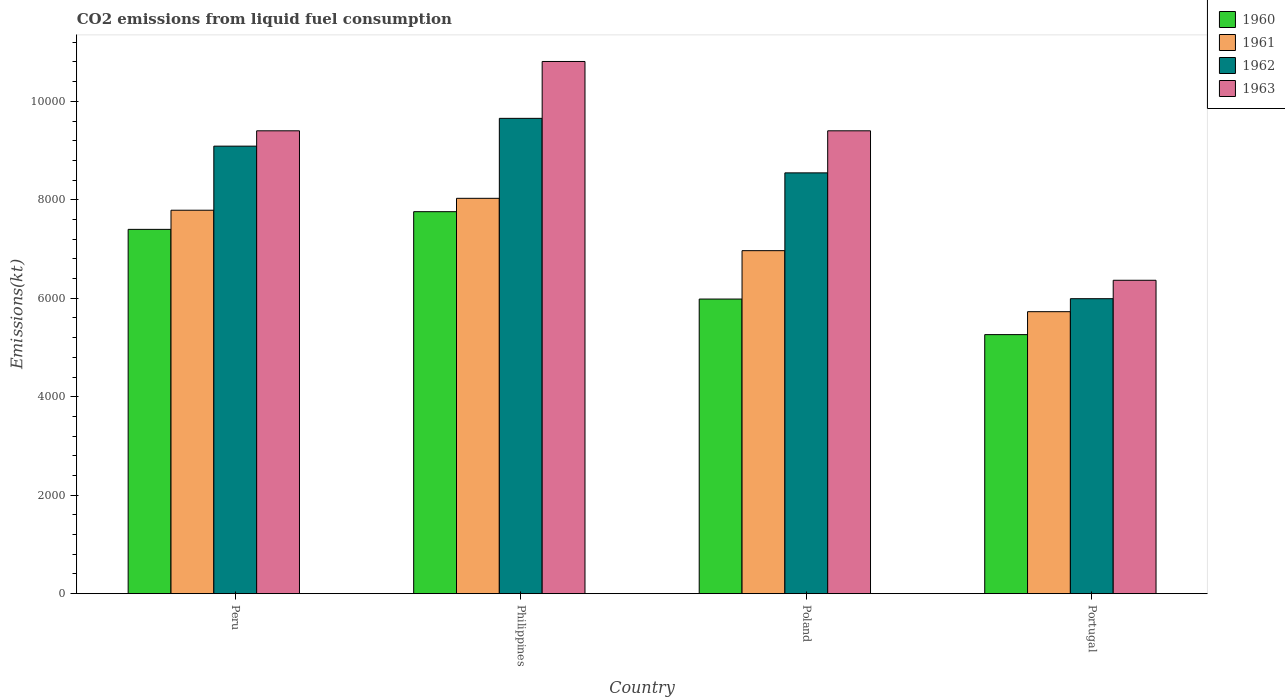Are the number of bars per tick equal to the number of legend labels?
Give a very brief answer. Yes. Are the number of bars on each tick of the X-axis equal?
Your answer should be compact. Yes. What is the label of the 2nd group of bars from the left?
Ensure brevity in your answer.  Philippines. What is the amount of CO2 emitted in 1960 in Poland?
Make the answer very short. 5984.54. Across all countries, what is the maximum amount of CO2 emitted in 1963?
Your answer should be compact. 1.08e+04. Across all countries, what is the minimum amount of CO2 emitted in 1960?
Provide a short and direct response. 5262.15. In which country was the amount of CO2 emitted in 1961 minimum?
Your answer should be very brief. Portugal. What is the total amount of CO2 emitted in 1963 in the graph?
Offer a very short reply. 3.60e+04. What is the difference between the amount of CO2 emitted in 1961 in Peru and that in Philippines?
Make the answer very short. -242.02. What is the difference between the amount of CO2 emitted in 1962 in Portugal and the amount of CO2 emitted in 1961 in Philippines?
Ensure brevity in your answer.  -2038.85. What is the average amount of CO2 emitted in 1962 per country?
Offer a very short reply. 8321.34. What is the difference between the amount of CO2 emitted of/in 1963 and amount of CO2 emitted of/in 1961 in Philippines?
Make the answer very short. 2779.59. What is the ratio of the amount of CO2 emitted in 1962 in Philippines to that in Poland?
Ensure brevity in your answer.  1.13. Is the amount of CO2 emitted in 1960 in Peru less than that in Portugal?
Provide a short and direct response. No. What is the difference between the highest and the second highest amount of CO2 emitted in 1963?
Your answer should be compact. -1408.13. What is the difference between the highest and the lowest amount of CO2 emitted in 1960?
Offer a very short reply. 2497.23. In how many countries, is the amount of CO2 emitted in 1960 greater than the average amount of CO2 emitted in 1960 taken over all countries?
Provide a succinct answer. 2. What does the 1st bar from the left in Peru represents?
Your answer should be very brief. 1960. What does the 1st bar from the right in Poland represents?
Your answer should be compact. 1963. Is it the case that in every country, the sum of the amount of CO2 emitted in 1963 and amount of CO2 emitted in 1961 is greater than the amount of CO2 emitted in 1962?
Your response must be concise. Yes. Are all the bars in the graph horizontal?
Your answer should be compact. No. What is the difference between two consecutive major ticks on the Y-axis?
Your answer should be very brief. 2000. Does the graph contain grids?
Your response must be concise. No. How many legend labels are there?
Offer a terse response. 4. What is the title of the graph?
Your response must be concise. CO2 emissions from liquid fuel consumption. What is the label or title of the Y-axis?
Ensure brevity in your answer.  Emissions(kt). What is the Emissions(kt) of 1960 in Peru?
Offer a terse response. 7400.01. What is the Emissions(kt) in 1961 in Peru?
Your response must be concise. 7788.71. What is the Emissions(kt) of 1962 in Peru?
Your response must be concise. 9090.49. What is the Emissions(kt) of 1963 in Peru?
Your answer should be very brief. 9402.19. What is the Emissions(kt) of 1960 in Philippines?
Provide a short and direct response. 7759.37. What is the Emissions(kt) in 1961 in Philippines?
Your response must be concise. 8030.73. What is the Emissions(kt) of 1962 in Philippines?
Your response must be concise. 9655.21. What is the Emissions(kt) of 1963 in Philippines?
Provide a short and direct response. 1.08e+04. What is the Emissions(kt) of 1960 in Poland?
Offer a terse response. 5984.54. What is the Emissions(kt) of 1961 in Poland?
Give a very brief answer. 6967.3. What is the Emissions(kt) in 1962 in Poland?
Provide a succinct answer. 8547.78. What is the Emissions(kt) of 1963 in Poland?
Offer a terse response. 9402.19. What is the Emissions(kt) of 1960 in Portugal?
Provide a short and direct response. 5262.15. What is the Emissions(kt) in 1961 in Portugal?
Offer a terse response. 5727.85. What is the Emissions(kt) of 1962 in Portugal?
Make the answer very short. 5991.88. What is the Emissions(kt) of 1963 in Portugal?
Give a very brief answer. 6365.91. Across all countries, what is the maximum Emissions(kt) of 1960?
Offer a terse response. 7759.37. Across all countries, what is the maximum Emissions(kt) in 1961?
Your answer should be compact. 8030.73. Across all countries, what is the maximum Emissions(kt) of 1962?
Provide a succinct answer. 9655.21. Across all countries, what is the maximum Emissions(kt) of 1963?
Your answer should be compact. 1.08e+04. Across all countries, what is the minimum Emissions(kt) of 1960?
Provide a succinct answer. 5262.15. Across all countries, what is the minimum Emissions(kt) in 1961?
Provide a short and direct response. 5727.85. Across all countries, what is the minimum Emissions(kt) of 1962?
Make the answer very short. 5991.88. Across all countries, what is the minimum Emissions(kt) of 1963?
Ensure brevity in your answer.  6365.91. What is the total Emissions(kt) in 1960 in the graph?
Make the answer very short. 2.64e+04. What is the total Emissions(kt) in 1961 in the graph?
Your answer should be very brief. 2.85e+04. What is the total Emissions(kt) in 1962 in the graph?
Give a very brief answer. 3.33e+04. What is the total Emissions(kt) of 1963 in the graph?
Your response must be concise. 3.60e+04. What is the difference between the Emissions(kt) in 1960 in Peru and that in Philippines?
Your answer should be very brief. -359.37. What is the difference between the Emissions(kt) of 1961 in Peru and that in Philippines?
Your answer should be very brief. -242.02. What is the difference between the Emissions(kt) in 1962 in Peru and that in Philippines?
Provide a succinct answer. -564.72. What is the difference between the Emissions(kt) in 1963 in Peru and that in Philippines?
Keep it short and to the point. -1408.13. What is the difference between the Emissions(kt) in 1960 in Peru and that in Poland?
Provide a succinct answer. 1415.46. What is the difference between the Emissions(kt) in 1961 in Peru and that in Poland?
Give a very brief answer. 821.41. What is the difference between the Emissions(kt) of 1962 in Peru and that in Poland?
Provide a succinct answer. 542.72. What is the difference between the Emissions(kt) in 1963 in Peru and that in Poland?
Offer a very short reply. 0. What is the difference between the Emissions(kt) of 1960 in Peru and that in Portugal?
Make the answer very short. 2137.86. What is the difference between the Emissions(kt) of 1961 in Peru and that in Portugal?
Offer a very short reply. 2060.85. What is the difference between the Emissions(kt) of 1962 in Peru and that in Portugal?
Offer a terse response. 3098.61. What is the difference between the Emissions(kt) of 1963 in Peru and that in Portugal?
Offer a very short reply. 3036.28. What is the difference between the Emissions(kt) of 1960 in Philippines and that in Poland?
Your response must be concise. 1774.83. What is the difference between the Emissions(kt) in 1961 in Philippines and that in Poland?
Make the answer very short. 1063.43. What is the difference between the Emissions(kt) of 1962 in Philippines and that in Poland?
Offer a terse response. 1107.43. What is the difference between the Emissions(kt) in 1963 in Philippines and that in Poland?
Offer a very short reply. 1408.13. What is the difference between the Emissions(kt) of 1960 in Philippines and that in Portugal?
Offer a terse response. 2497.23. What is the difference between the Emissions(kt) of 1961 in Philippines and that in Portugal?
Your response must be concise. 2302.88. What is the difference between the Emissions(kt) of 1962 in Philippines and that in Portugal?
Ensure brevity in your answer.  3663.33. What is the difference between the Emissions(kt) in 1963 in Philippines and that in Portugal?
Offer a terse response. 4444.4. What is the difference between the Emissions(kt) of 1960 in Poland and that in Portugal?
Ensure brevity in your answer.  722.4. What is the difference between the Emissions(kt) in 1961 in Poland and that in Portugal?
Offer a very short reply. 1239.45. What is the difference between the Emissions(kt) of 1962 in Poland and that in Portugal?
Your response must be concise. 2555.9. What is the difference between the Emissions(kt) in 1963 in Poland and that in Portugal?
Make the answer very short. 3036.28. What is the difference between the Emissions(kt) of 1960 in Peru and the Emissions(kt) of 1961 in Philippines?
Make the answer very short. -630.72. What is the difference between the Emissions(kt) of 1960 in Peru and the Emissions(kt) of 1962 in Philippines?
Your response must be concise. -2255.2. What is the difference between the Emissions(kt) in 1960 in Peru and the Emissions(kt) in 1963 in Philippines?
Your answer should be very brief. -3410.31. What is the difference between the Emissions(kt) in 1961 in Peru and the Emissions(kt) in 1962 in Philippines?
Ensure brevity in your answer.  -1866.5. What is the difference between the Emissions(kt) of 1961 in Peru and the Emissions(kt) of 1963 in Philippines?
Provide a succinct answer. -3021.61. What is the difference between the Emissions(kt) of 1962 in Peru and the Emissions(kt) of 1963 in Philippines?
Ensure brevity in your answer.  -1719.82. What is the difference between the Emissions(kt) of 1960 in Peru and the Emissions(kt) of 1961 in Poland?
Provide a succinct answer. 432.71. What is the difference between the Emissions(kt) in 1960 in Peru and the Emissions(kt) in 1962 in Poland?
Ensure brevity in your answer.  -1147.77. What is the difference between the Emissions(kt) of 1960 in Peru and the Emissions(kt) of 1963 in Poland?
Your answer should be compact. -2002.18. What is the difference between the Emissions(kt) in 1961 in Peru and the Emissions(kt) in 1962 in Poland?
Your answer should be compact. -759.07. What is the difference between the Emissions(kt) of 1961 in Peru and the Emissions(kt) of 1963 in Poland?
Your response must be concise. -1613.48. What is the difference between the Emissions(kt) in 1962 in Peru and the Emissions(kt) in 1963 in Poland?
Offer a terse response. -311.69. What is the difference between the Emissions(kt) in 1960 in Peru and the Emissions(kt) in 1961 in Portugal?
Offer a very short reply. 1672.15. What is the difference between the Emissions(kt) of 1960 in Peru and the Emissions(kt) of 1962 in Portugal?
Your answer should be compact. 1408.13. What is the difference between the Emissions(kt) in 1960 in Peru and the Emissions(kt) in 1963 in Portugal?
Ensure brevity in your answer.  1034.09. What is the difference between the Emissions(kt) in 1961 in Peru and the Emissions(kt) in 1962 in Portugal?
Keep it short and to the point. 1796.83. What is the difference between the Emissions(kt) in 1961 in Peru and the Emissions(kt) in 1963 in Portugal?
Provide a short and direct response. 1422.8. What is the difference between the Emissions(kt) of 1962 in Peru and the Emissions(kt) of 1963 in Portugal?
Offer a terse response. 2724.58. What is the difference between the Emissions(kt) of 1960 in Philippines and the Emissions(kt) of 1961 in Poland?
Give a very brief answer. 792.07. What is the difference between the Emissions(kt) in 1960 in Philippines and the Emissions(kt) in 1962 in Poland?
Give a very brief answer. -788.4. What is the difference between the Emissions(kt) in 1960 in Philippines and the Emissions(kt) in 1963 in Poland?
Keep it short and to the point. -1642.82. What is the difference between the Emissions(kt) in 1961 in Philippines and the Emissions(kt) in 1962 in Poland?
Offer a terse response. -517.05. What is the difference between the Emissions(kt) in 1961 in Philippines and the Emissions(kt) in 1963 in Poland?
Keep it short and to the point. -1371.46. What is the difference between the Emissions(kt) of 1962 in Philippines and the Emissions(kt) of 1963 in Poland?
Provide a short and direct response. 253.02. What is the difference between the Emissions(kt) in 1960 in Philippines and the Emissions(kt) in 1961 in Portugal?
Your answer should be very brief. 2031.52. What is the difference between the Emissions(kt) of 1960 in Philippines and the Emissions(kt) of 1962 in Portugal?
Keep it short and to the point. 1767.49. What is the difference between the Emissions(kt) of 1960 in Philippines and the Emissions(kt) of 1963 in Portugal?
Ensure brevity in your answer.  1393.46. What is the difference between the Emissions(kt) in 1961 in Philippines and the Emissions(kt) in 1962 in Portugal?
Provide a short and direct response. 2038.85. What is the difference between the Emissions(kt) in 1961 in Philippines and the Emissions(kt) in 1963 in Portugal?
Make the answer very short. 1664.82. What is the difference between the Emissions(kt) of 1962 in Philippines and the Emissions(kt) of 1963 in Portugal?
Your answer should be very brief. 3289.3. What is the difference between the Emissions(kt) of 1960 in Poland and the Emissions(kt) of 1961 in Portugal?
Offer a terse response. 256.69. What is the difference between the Emissions(kt) of 1960 in Poland and the Emissions(kt) of 1962 in Portugal?
Offer a very short reply. -7.33. What is the difference between the Emissions(kt) in 1960 in Poland and the Emissions(kt) in 1963 in Portugal?
Offer a very short reply. -381.37. What is the difference between the Emissions(kt) in 1961 in Poland and the Emissions(kt) in 1962 in Portugal?
Make the answer very short. 975.42. What is the difference between the Emissions(kt) of 1961 in Poland and the Emissions(kt) of 1963 in Portugal?
Provide a succinct answer. 601.39. What is the difference between the Emissions(kt) of 1962 in Poland and the Emissions(kt) of 1963 in Portugal?
Offer a terse response. 2181.86. What is the average Emissions(kt) of 1960 per country?
Provide a short and direct response. 6601.52. What is the average Emissions(kt) in 1961 per country?
Your answer should be compact. 7128.65. What is the average Emissions(kt) in 1962 per country?
Provide a succinct answer. 8321.34. What is the average Emissions(kt) of 1963 per country?
Provide a succinct answer. 8995.15. What is the difference between the Emissions(kt) of 1960 and Emissions(kt) of 1961 in Peru?
Give a very brief answer. -388.7. What is the difference between the Emissions(kt) in 1960 and Emissions(kt) in 1962 in Peru?
Give a very brief answer. -1690.49. What is the difference between the Emissions(kt) of 1960 and Emissions(kt) of 1963 in Peru?
Make the answer very short. -2002.18. What is the difference between the Emissions(kt) in 1961 and Emissions(kt) in 1962 in Peru?
Your answer should be very brief. -1301.79. What is the difference between the Emissions(kt) of 1961 and Emissions(kt) of 1963 in Peru?
Make the answer very short. -1613.48. What is the difference between the Emissions(kt) in 1962 and Emissions(kt) in 1963 in Peru?
Offer a very short reply. -311.69. What is the difference between the Emissions(kt) in 1960 and Emissions(kt) in 1961 in Philippines?
Provide a short and direct response. -271.36. What is the difference between the Emissions(kt) in 1960 and Emissions(kt) in 1962 in Philippines?
Provide a short and direct response. -1895.84. What is the difference between the Emissions(kt) in 1960 and Emissions(kt) in 1963 in Philippines?
Provide a succinct answer. -3050.94. What is the difference between the Emissions(kt) of 1961 and Emissions(kt) of 1962 in Philippines?
Your response must be concise. -1624.48. What is the difference between the Emissions(kt) of 1961 and Emissions(kt) of 1963 in Philippines?
Give a very brief answer. -2779.59. What is the difference between the Emissions(kt) of 1962 and Emissions(kt) of 1963 in Philippines?
Your answer should be compact. -1155.11. What is the difference between the Emissions(kt) in 1960 and Emissions(kt) in 1961 in Poland?
Offer a terse response. -982.76. What is the difference between the Emissions(kt) in 1960 and Emissions(kt) in 1962 in Poland?
Give a very brief answer. -2563.23. What is the difference between the Emissions(kt) in 1960 and Emissions(kt) in 1963 in Poland?
Your response must be concise. -3417.64. What is the difference between the Emissions(kt) of 1961 and Emissions(kt) of 1962 in Poland?
Provide a succinct answer. -1580.48. What is the difference between the Emissions(kt) of 1961 and Emissions(kt) of 1963 in Poland?
Offer a very short reply. -2434.89. What is the difference between the Emissions(kt) in 1962 and Emissions(kt) in 1963 in Poland?
Ensure brevity in your answer.  -854.41. What is the difference between the Emissions(kt) in 1960 and Emissions(kt) in 1961 in Portugal?
Provide a succinct answer. -465.71. What is the difference between the Emissions(kt) of 1960 and Emissions(kt) of 1962 in Portugal?
Your answer should be very brief. -729.73. What is the difference between the Emissions(kt) in 1960 and Emissions(kt) in 1963 in Portugal?
Provide a short and direct response. -1103.77. What is the difference between the Emissions(kt) of 1961 and Emissions(kt) of 1962 in Portugal?
Make the answer very short. -264.02. What is the difference between the Emissions(kt) in 1961 and Emissions(kt) in 1963 in Portugal?
Offer a terse response. -638.06. What is the difference between the Emissions(kt) of 1962 and Emissions(kt) of 1963 in Portugal?
Make the answer very short. -374.03. What is the ratio of the Emissions(kt) of 1960 in Peru to that in Philippines?
Provide a short and direct response. 0.95. What is the ratio of the Emissions(kt) of 1961 in Peru to that in Philippines?
Give a very brief answer. 0.97. What is the ratio of the Emissions(kt) of 1962 in Peru to that in Philippines?
Your answer should be very brief. 0.94. What is the ratio of the Emissions(kt) of 1963 in Peru to that in Philippines?
Provide a succinct answer. 0.87. What is the ratio of the Emissions(kt) in 1960 in Peru to that in Poland?
Make the answer very short. 1.24. What is the ratio of the Emissions(kt) in 1961 in Peru to that in Poland?
Ensure brevity in your answer.  1.12. What is the ratio of the Emissions(kt) in 1962 in Peru to that in Poland?
Provide a succinct answer. 1.06. What is the ratio of the Emissions(kt) of 1963 in Peru to that in Poland?
Provide a short and direct response. 1. What is the ratio of the Emissions(kt) of 1960 in Peru to that in Portugal?
Your answer should be very brief. 1.41. What is the ratio of the Emissions(kt) of 1961 in Peru to that in Portugal?
Offer a very short reply. 1.36. What is the ratio of the Emissions(kt) in 1962 in Peru to that in Portugal?
Offer a terse response. 1.52. What is the ratio of the Emissions(kt) of 1963 in Peru to that in Portugal?
Make the answer very short. 1.48. What is the ratio of the Emissions(kt) in 1960 in Philippines to that in Poland?
Your answer should be compact. 1.3. What is the ratio of the Emissions(kt) of 1961 in Philippines to that in Poland?
Your response must be concise. 1.15. What is the ratio of the Emissions(kt) of 1962 in Philippines to that in Poland?
Offer a terse response. 1.13. What is the ratio of the Emissions(kt) in 1963 in Philippines to that in Poland?
Give a very brief answer. 1.15. What is the ratio of the Emissions(kt) of 1960 in Philippines to that in Portugal?
Your response must be concise. 1.47. What is the ratio of the Emissions(kt) in 1961 in Philippines to that in Portugal?
Your response must be concise. 1.4. What is the ratio of the Emissions(kt) in 1962 in Philippines to that in Portugal?
Offer a terse response. 1.61. What is the ratio of the Emissions(kt) of 1963 in Philippines to that in Portugal?
Your answer should be compact. 1.7. What is the ratio of the Emissions(kt) of 1960 in Poland to that in Portugal?
Provide a succinct answer. 1.14. What is the ratio of the Emissions(kt) of 1961 in Poland to that in Portugal?
Make the answer very short. 1.22. What is the ratio of the Emissions(kt) in 1962 in Poland to that in Portugal?
Your response must be concise. 1.43. What is the ratio of the Emissions(kt) in 1963 in Poland to that in Portugal?
Offer a terse response. 1.48. What is the difference between the highest and the second highest Emissions(kt) in 1960?
Provide a succinct answer. 359.37. What is the difference between the highest and the second highest Emissions(kt) of 1961?
Your response must be concise. 242.02. What is the difference between the highest and the second highest Emissions(kt) in 1962?
Make the answer very short. 564.72. What is the difference between the highest and the second highest Emissions(kt) of 1963?
Make the answer very short. 1408.13. What is the difference between the highest and the lowest Emissions(kt) in 1960?
Ensure brevity in your answer.  2497.23. What is the difference between the highest and the lowest Emissions(kt) in 1961?
Give a very brief answer. 2302.88. What is the difference between the highest and the lowest Emissions(kt) of 1962?
Provide a short and direct response. 3663.33. What is the difference between the highest and the lowest Emissions(kt) in 1963?
Ensure brevity in your answer.  4444.4. 